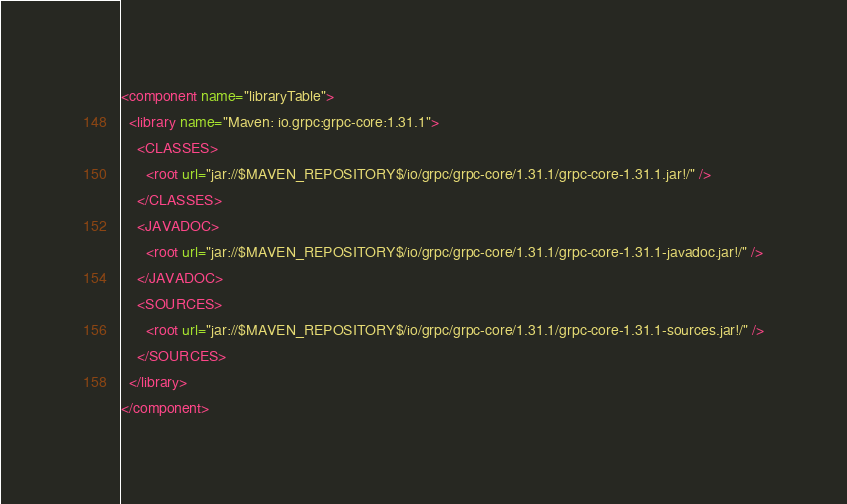Convert code to text. <code><loc_0><loc_0><loc_500><loc_500><_XML_><component name="libraryTable">
  <library name="Maven: io.grpc:grpc-core:1.31.1">
    <CLASSES>
      <root url="jar://$MAVEN_REPOSITORY$/io/grpc/grpc-core/1.31.1/grpc-core-1.31.1.jar!/" />
    </CLASSES>
    <JAVADOC>
      <root url="jar://$MAVEN_REPOSITORY$/io/grpc/grpc-core/1.31.1/grpc-core-1.31.1-javadoc.jar!/" />
    </JAVADOC>
    <SOURCES>
      <root url="jar://$MAVEN_REPOSITORY$/io/grpc/grpc-core/1.31.1/grpc-core-1.31.1-sources.jar!/" />
    </SOURCES>
  </library>
</component></code> 